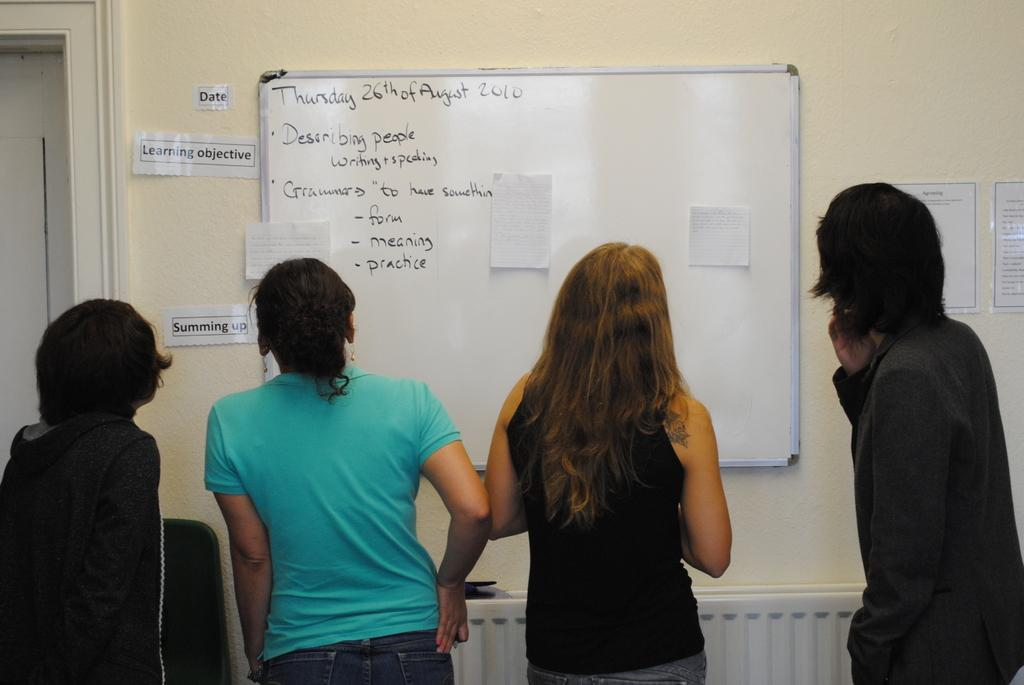<image>
Provide a brief description of the given image. A group of people looking at a white board on August 26. 